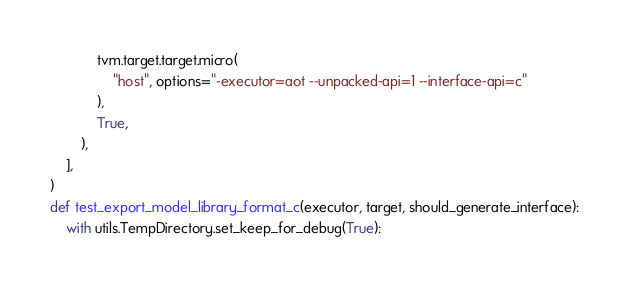Convert code to text. <code><loc_0><loc_0><loc_500><loc_500><_Python_>            tvm.target.target.micro(
                "host", options="-executor=aot --unpacked-api=1 --interface-api=c"
            ),
            True,
        ),
    ],
)
def test_export_model_library_format_c(executor, target, should_generate_interface):
    with utils.TempDirectory.set_keep_for_debug(True):</code> 